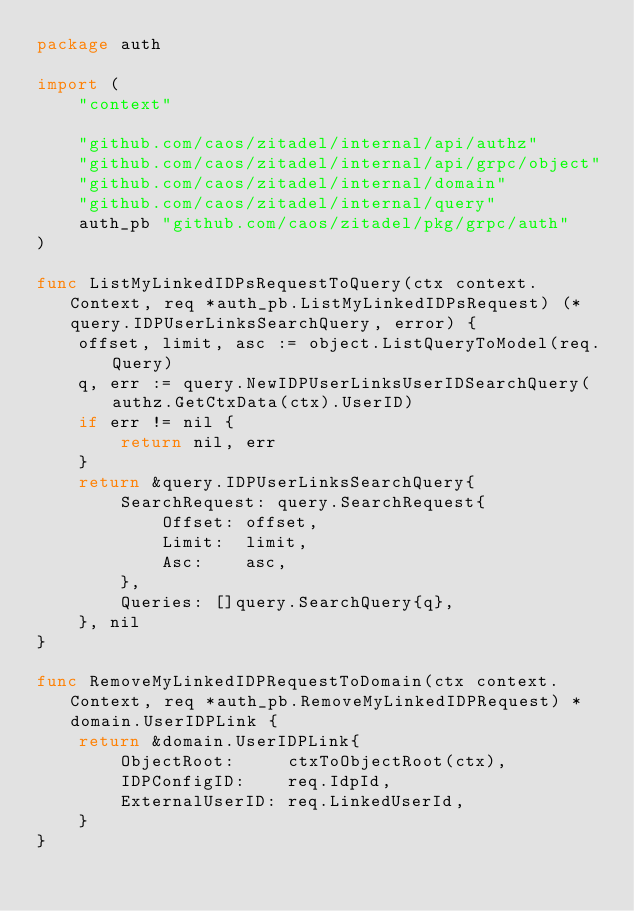<code> <loc_0><loc_0><loc_500><loc_500><_Go_>package auth

import (
	"context"

	"github.com/caos/zitadel/internal/api/authz"
	"github.com/caos/zitadel/internal/api/grpc/object"
	"github.com/caos/zitadel/internal/domain"
	"github.com/caos/zitadel/internal/query"
	auth_pb "github.com/caos/zitadel/pkg/grpc/auth"
)

func ListMyLinkedIDPsRequestToQuery(ctx context.Context, req *auth_pb.ListMyLinkedIDPsRequest) (*query.IDPUserLinksSearchQuery, error) {
	offset, limit, asc := object.ListQueryToModel(req.Query)
	q, err := query.NewIDPUserLinksUserIDSearchQuery(authz.GetCtxData(ctx).UserID)
	if err != nil {
		return nil, err
	}
	return &query.IDPUserLinksSearchQuery{
		SearchRequest: query.SearchRequest{
			Offset: offset,
			Limit:  limit,
			Asc:    asc,
		},
		Queries: []query.SearchQuery{q},
	}, nil
}

func RemoveMyLinkedIDPRequestToDomain(ctx context.Context, req *auth_pb.RemoveMyLinkedIDPRequest) *domain.UserIDPLink {
	return &domain.UserIDPLink{
		ObjectRoot:     ctxToObjectRoot(ctx),
		IDPConfigID:    req.IdpId,
		ExternalUserID: req.LinkedUserId,
	}
}
</code> 